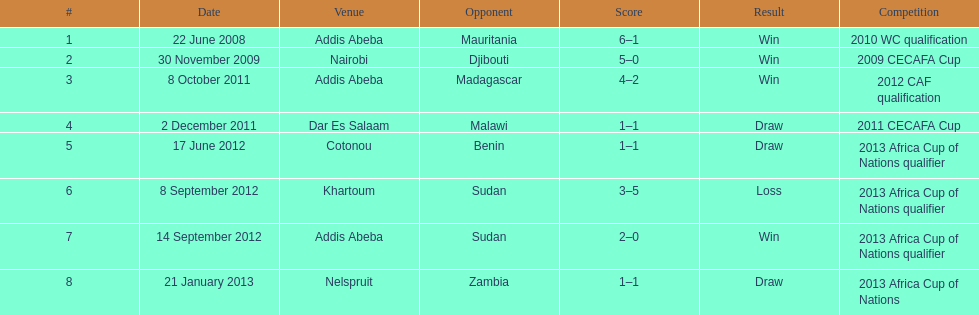Over how many years does this table cover extend? 5. 